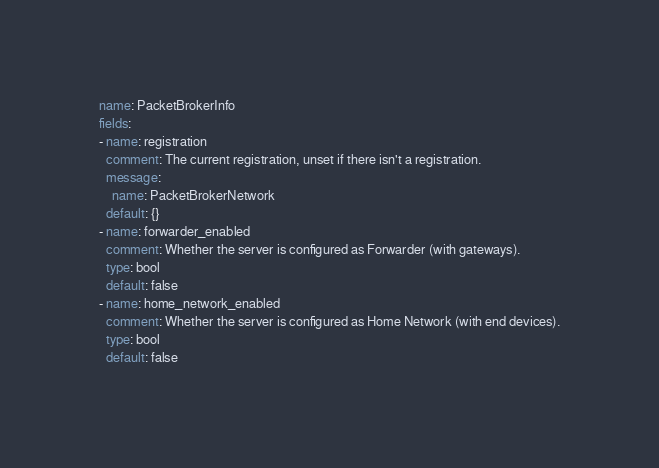<code> <loc_0><loc_0><loc_500><loc_500><_YAML_>name: PacketBrokerInfo
fields:
- name: registration
  comment: The current registration, unset if there isn't a registration.
  message:
    name: PacketBrokerNetwork
  default: {}
- name: forwarder_enabled
  comment: Whether the server is configured as Forwarder (with gateways).
  type: bool
  default: false
- name: home_network_enabled
  comment: Whether the server is configured as Home Network (with end devices).
  type: bool
  default: false
</code> 